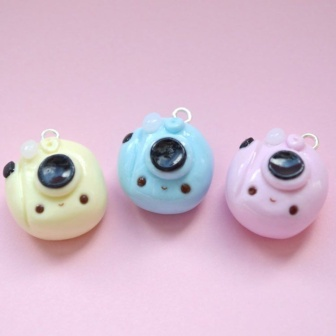Can you invent a short story involving these bird-shaped charms? Once upon a time, in a quaint little craft shop, there were three bird-shaped charms known as Chirpy, Blu, and Rosy. Chirpy, the yellow charm, loved to sing sweet melodies, Blu, the blue charm, adored the rain, and Rosy, the pink charm, cherished blooming flowers. Despite their differences, they shared a close bond and often dreamt of adventures beyond their cozy shelf. One sunny morning, a young girl named Lilly visited the shop and immediately fell in love with the adorable trio. She decided to adopt them and took them on all her whimsical adventures, from exploring enchanted forests to having picnics in lush meadows. The charms brought magic and joy to her days, their pastel hues blending perfectly with every scene, making each moment unforgettable. Imagine these bird-shaped charms could talk. What would they say to each other? Chirpy: 'Oh, what a lovely day! The sun is shining just for us. How about a little melody to celebrate?' Blu: 'That sounds wonderful, Chirpy. But let's not forget to dance under the next rain shower. There’s nothing quite like the gentle patter of rain on our shiny coats.' Rosy: 'And after that, we could visit the flower garden and admire the beautiful blooms. Each one is like a new friend waiting to be discovered!' Together, they giggled and made plans for their imaginary adventures, their voices filled with excitement and joy, creating their own little world of wonder and delight. 